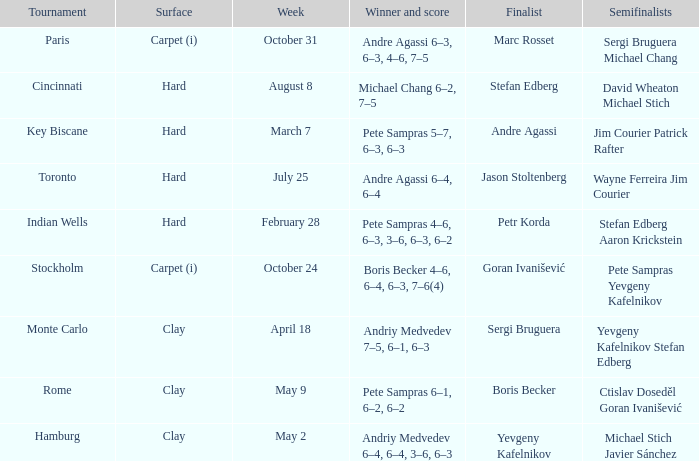Who was the semifinalist for the key biscane tournament? Jim Courier Patrick Rafter. 